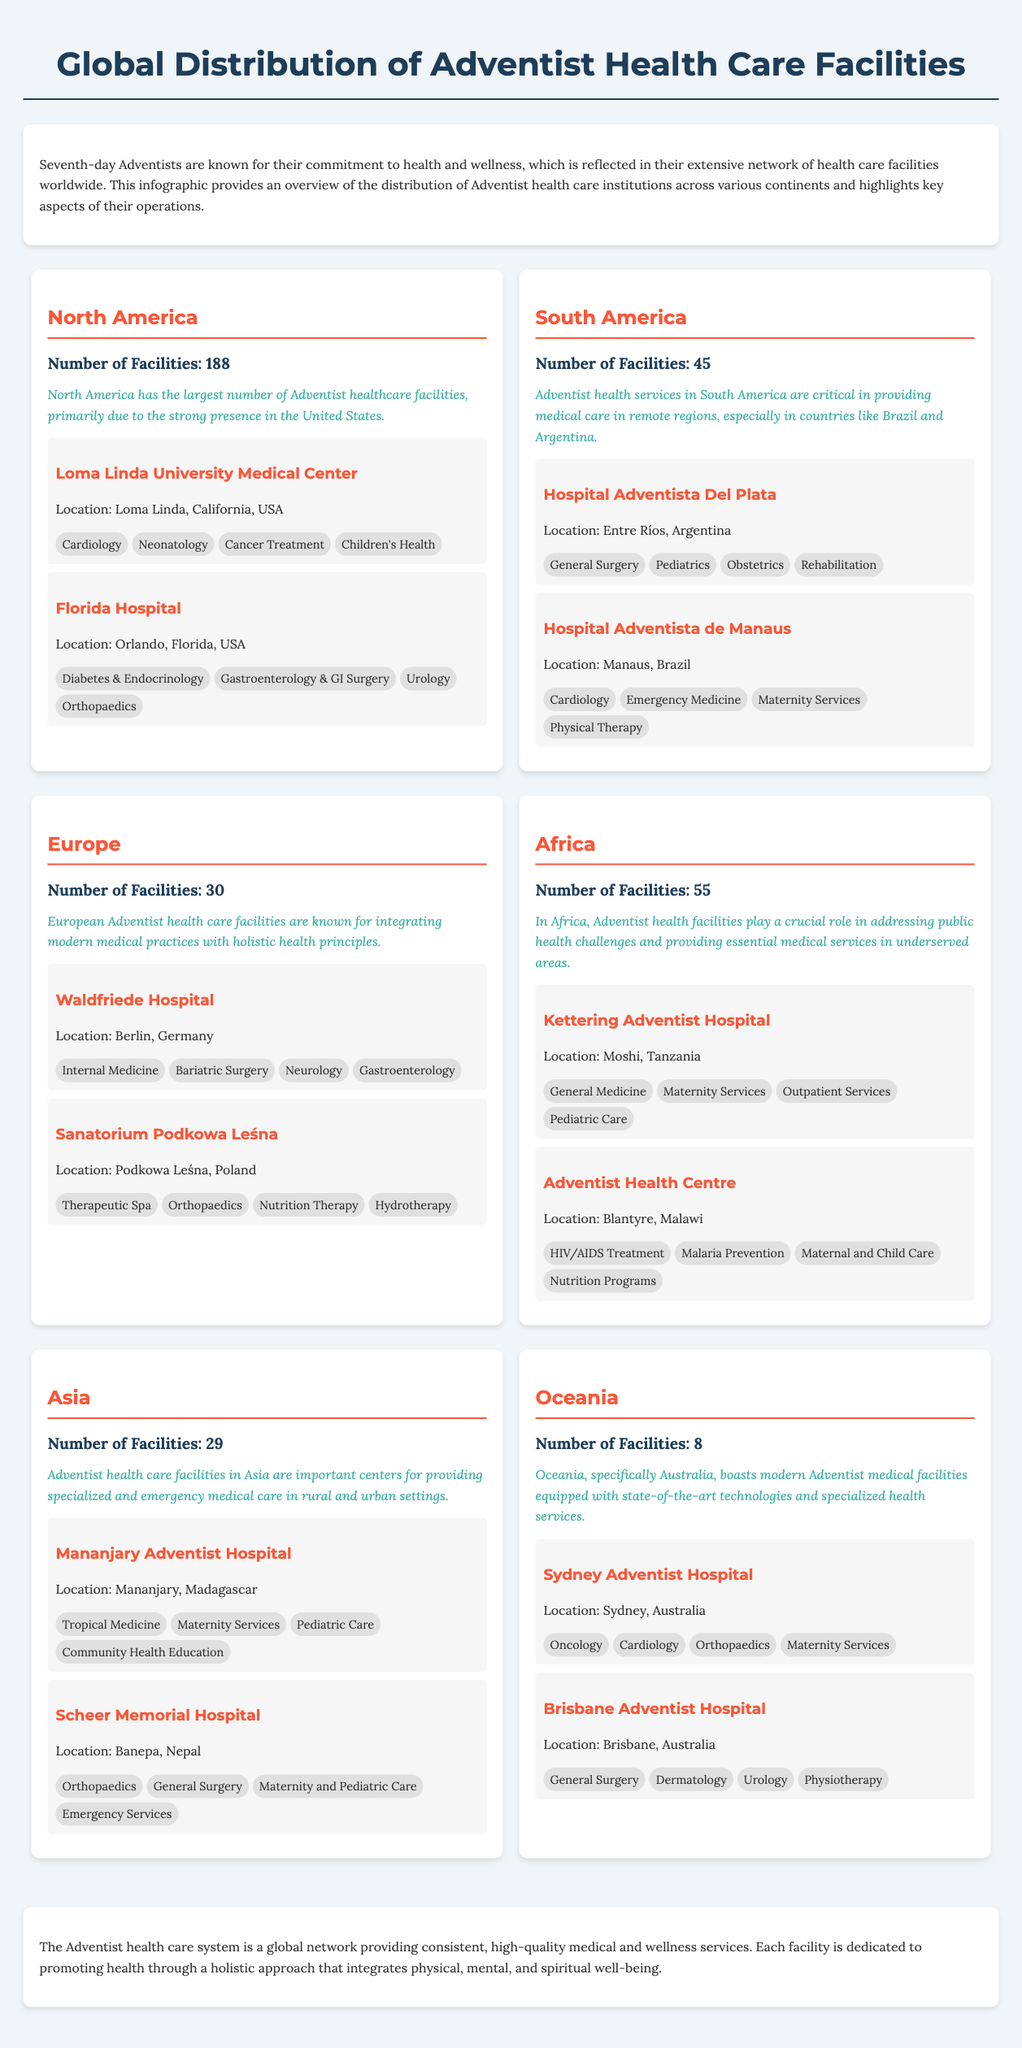What is the total number of Adventist health care facilities in North America? The document states that North America has the largest number of Adventist healthcare facilities with a total of 188.
Answer: 188 Which continent has 45 Adventist health care facilities? According to the infographic, South America has 45 Adventist health care facilities.
Answer: South America What notable facility is located in Tanzania? The document lists Kettering Adventist Hospital as a notable facility located in Moshi, Tanzania.
Answer: Kettering Adventist Hospital How many facilities are there in Oceania? The infographic shows that there are 8 Adventist health care facilities in Oceania.
Answer: 8 What service is provided at Loma Linda University Medical Center? The document mentions several services, including Cardiology, offered at Loma Linda University Medical Center.
Answer: Cardiology Which continent's facilities are known for integrating modern medical practices with holistic health principles? The infographic highlights that European Adventist health care facilities integrate modern practices with holistic principles.
Answer: Europe What notable facility is located in Brazil? The document lists Hospital Adventista de Manaus as a notable facility located in Manaus, Brazil.
Answer: Hospital Adventista de Manaus Which continent has the most notable focus on underserved areas? The document states that African facilities address public health challenges in underserved areas.
Answer: Africa What is a highlighted service provided at Sydney Adventist Hospital? The document states Oncology is one of the highlighted services at Sydney Adventist Hospital.
Answer: Oncology 